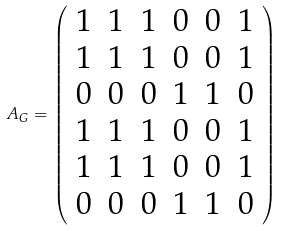Convert formula to latex. <formula><loc_0><loc_0><loc_500><loc_500>A _ { G } = \left ( \begin{array} { c c c c c c } 1 & 1 & 1 & 0 & 0 & 1 \\ 1 & 1 & 1 & 0 & 0 & 1 \\ 0 & 0 & 0 & 1 & 1 & 0 \\ 1 & 1 & 1 & 0 & 0 & 1 \\ 1 & 1 & 1 & 0 & 0 & 1 \\ 0 & 0 & 0 & 1 & 1 & 0 \\ \end{array} \right )</formula> 